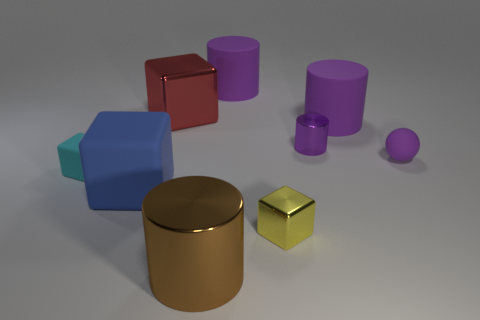Is the tiny sphere the same color as the small shiny cylinder?
Offer a very short reply. Yes. There is a large block on the left side of the metallic cube that is behind the purple ball; what color is it?
Offer a very short reply. Blue. What number of tiny yellow shiny balls are there?
Make the answer very short. 0. What number of shiny things are both in front of the small cylinder and behind the brown metallic cylinder?
Your answer should be very brief. 1. Is there any other thing that is the same shape as the purple metallic object?
Provide a succinct answer. Yes. There is a large shiny block; is its color the same as the matte cylinder that is left of the yellow cube?
Make the answer very short. No. The small rubber object to the right of the big metal cylinder has what shape?
Provide a short and direct response. Sphere. How many other objects are the same material as the small cyan block?
Your response must be concise. 4. What is the yellow object made of?
Ensure brevity in your answer.  Metal. How many small things are either red shiny things or rubber things?
Ensure brevity in your answer.  2. 